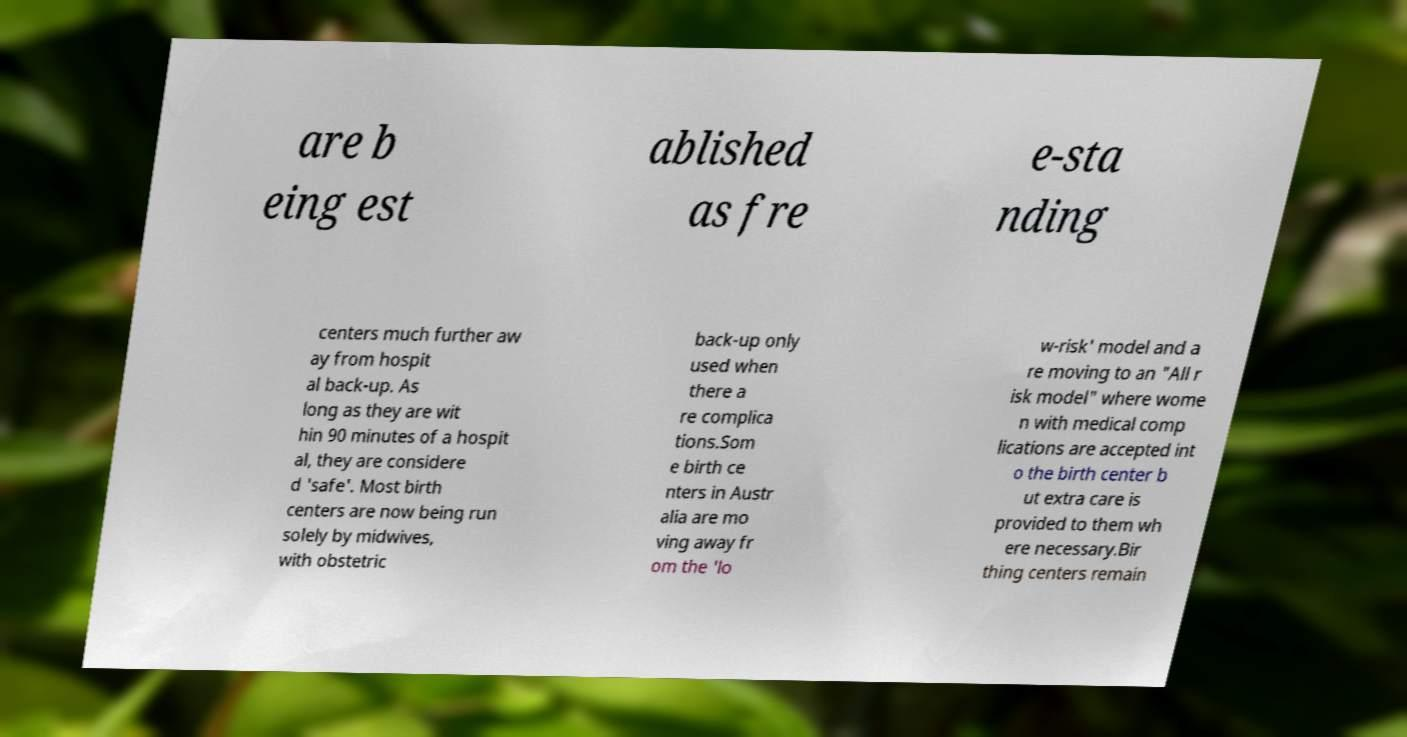Could you extract and type out the text from this image? are b eing est ablished as fre e-sta nding centers much further aw ay from hospit al back-up. As long as they are wit hin 90 minutes of a hospit al, they are considere d 'safe'. Most birth centers are now being run solely by midwives, with obstetric back-up only used when there a re complica tions.Som e birth ce nters in Austr alia are mo ving away fr om the 'lo w-risk' model and a re moving to an "All r isk model" where wome n with medical comp lications are accepted int o the birth center b ut extra care is provided to them wh ere necessary.Bir thing centers remain 